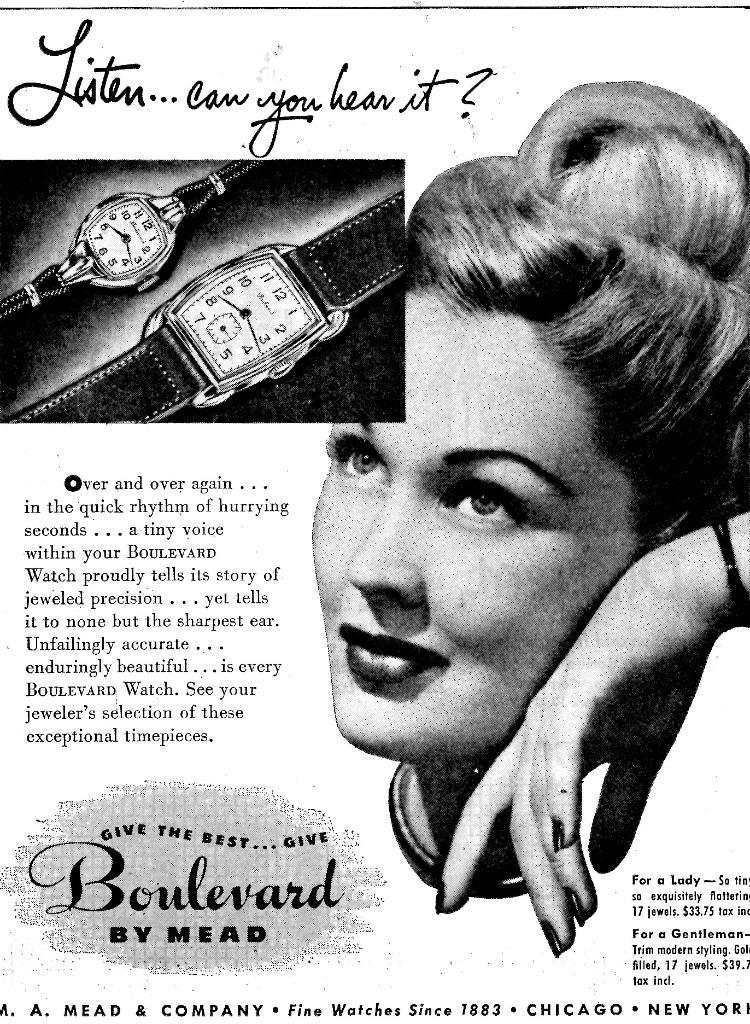What is the main subject of the image? The main subject of the image is an article. What can be seen within the article? The article contains a picture of a woman. Are there any objects related to the woman's picture? Yes, there are two watches beside the woman's picture. What is written at the bottom of the image? There is script at the bottom of the image. What type of pipe is the woman holding in the image? There is no pipe present in the image; the woman's picture is accompanied by two watches. What color is the orange beside the woman's picture? There is no orange present in the image; the objects beside the woman's picture are two watches. 